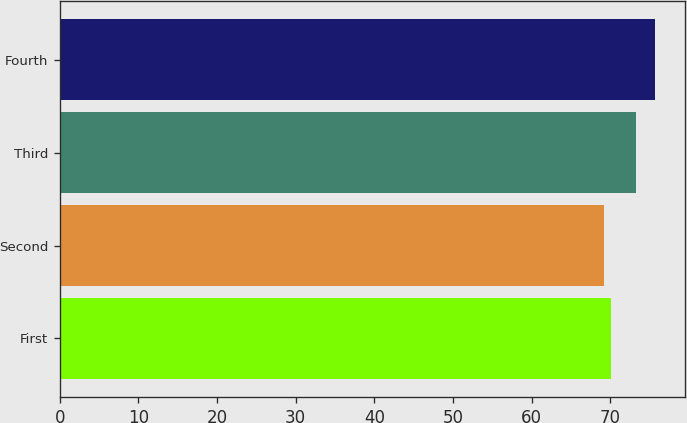Convert chart. <chart><loc_0><loc_0><loc_500><loc_500><bar_chart><fcel>First<fcel>Second<fcel>Third<fcel>Fourth<nl><fcel>70.12<fcel>69.17<fcel>73.29<fcel>75.68<nl></chart> 